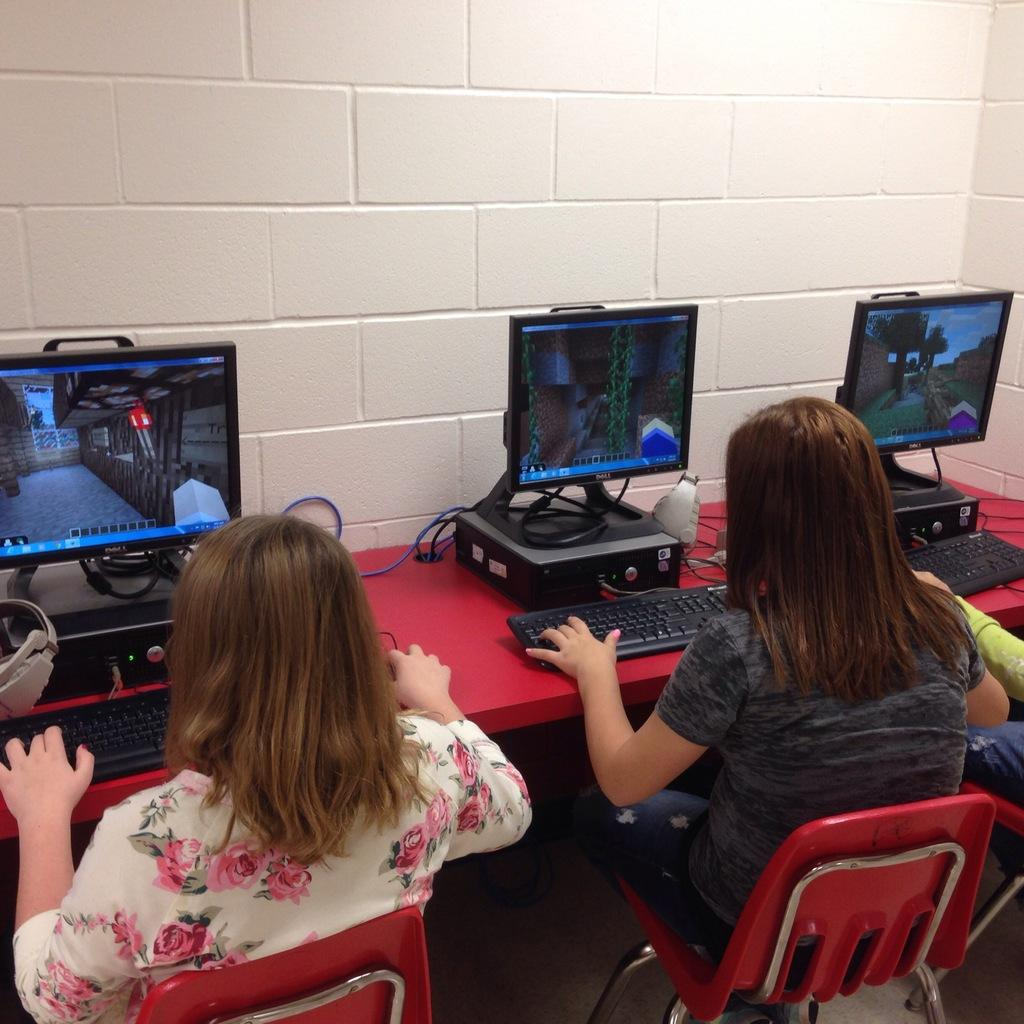Who is present in the image? There are women in the image. What are the women doing in the image? The women are seated on chairs. What objects can be seen on a table in the image? There are computers on a table in the image. What type of weather can be seen in the image? There is no weather depicted in the image; it is an indoor scene with women seated on chairs and computers on a table. Can you tell me how many crayons are being used by the women in the image? There are no crayons present in the image. 